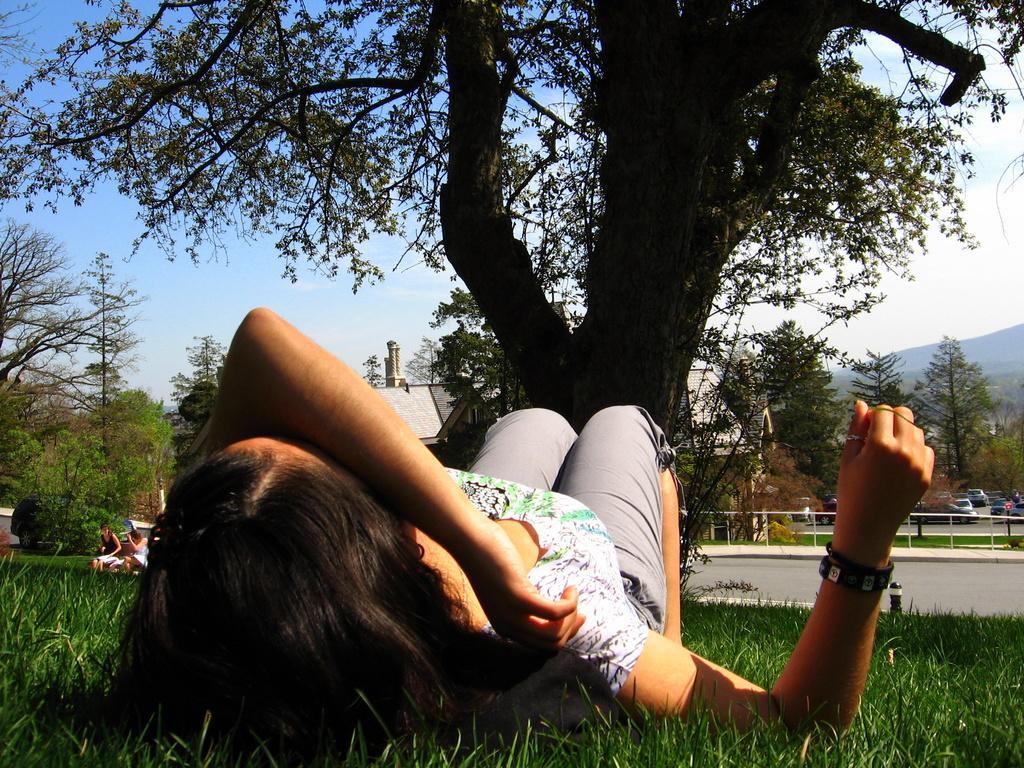In one or two sentences, can you explain what this image depicts? In this image we can see a person wearing white color top, ash color short sleeping on the ground, there is grass and in the background of the image there are two persons sitting, there is road, fencing and some vehicles parked, there are some trees and top of the image there is clear sky. 